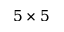<formula> <loc_0><loc_0><loc_500><loc_500>5 \times 5</formula> 